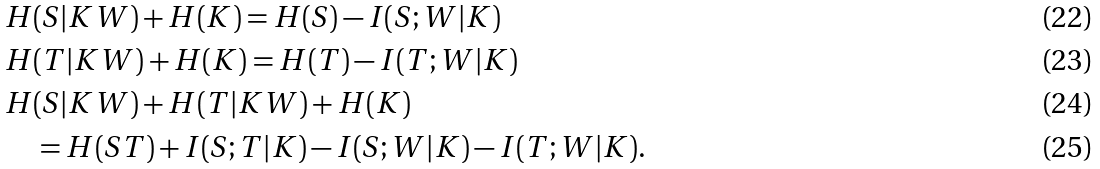<formula> <loc_0><loc_0><loc_500><loc_500>& H ( S | K W ) + H ( K ) = H ( S ) - I ( S ; W | K ) \\ & H ( T | K W ) + H ( K ) = H ( T ) - I ( T ; W | K ) \\ & H ( S | K W ) + H ( T | K W ) + H ( K ) \\ & \quad = H ( S T ) + I ( S ; T | K ) - I ( S ; W | K ) - I ( T ; W | K ) .</formula> 